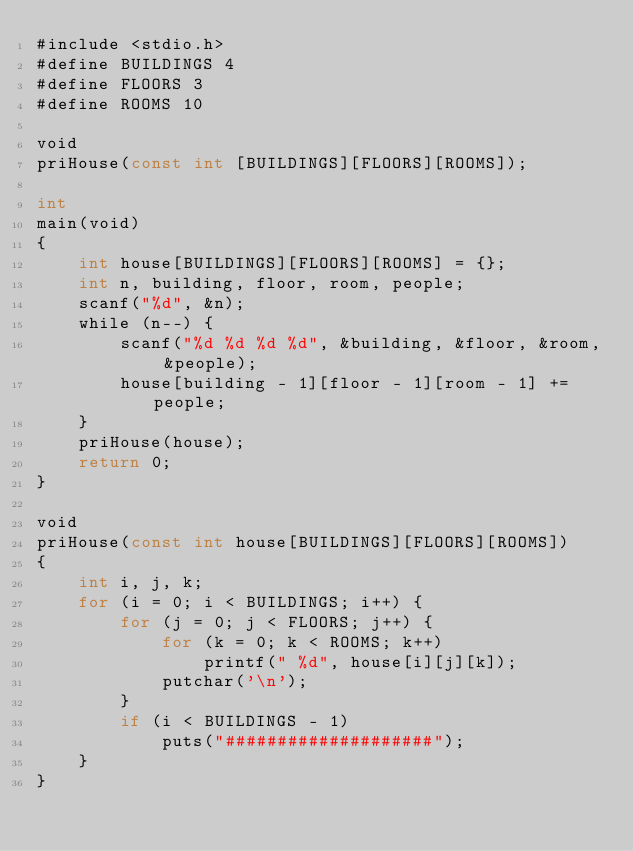Convert code to text. <code><loc_0><loc_0><loc_500><loc_500><_Go_>#include <stdio.h>
#define BUILDINGS 4
#define FLOORS 3
#define ROOMS 10

void
priHouse(const int [BUILDINGS][FLOORS][ROOMS]);

int
main(void)
{
    int house[BUILDINGS][FLOORS][ROOMS] = {};
    int n, building, floor, room, people;
    scanf("%d", &n);
    while (n--) {
        scanf("%d %d %d %d", &building, &floor, &room, &people);
        house[building - 1][floor - 1][room - 1] += people;
    }
    priHouse(house);
    return 0;
}

void
priHouse(const int house[BUILDINGS][FLOORS][ROOMS])
{
    int i, j, k;
    for (i = 0; i < BUILDINGS; i++) {
        for (j = 0; j < FLOORS; j++) {
            for (k = 0; k < ROOMS; k++)
                printf(" %d", house[i][j][k]);
            putchar('\n');
        }
        if (i < BUILDINGS - 1)
            puts("####################");
    }
}
</code> 